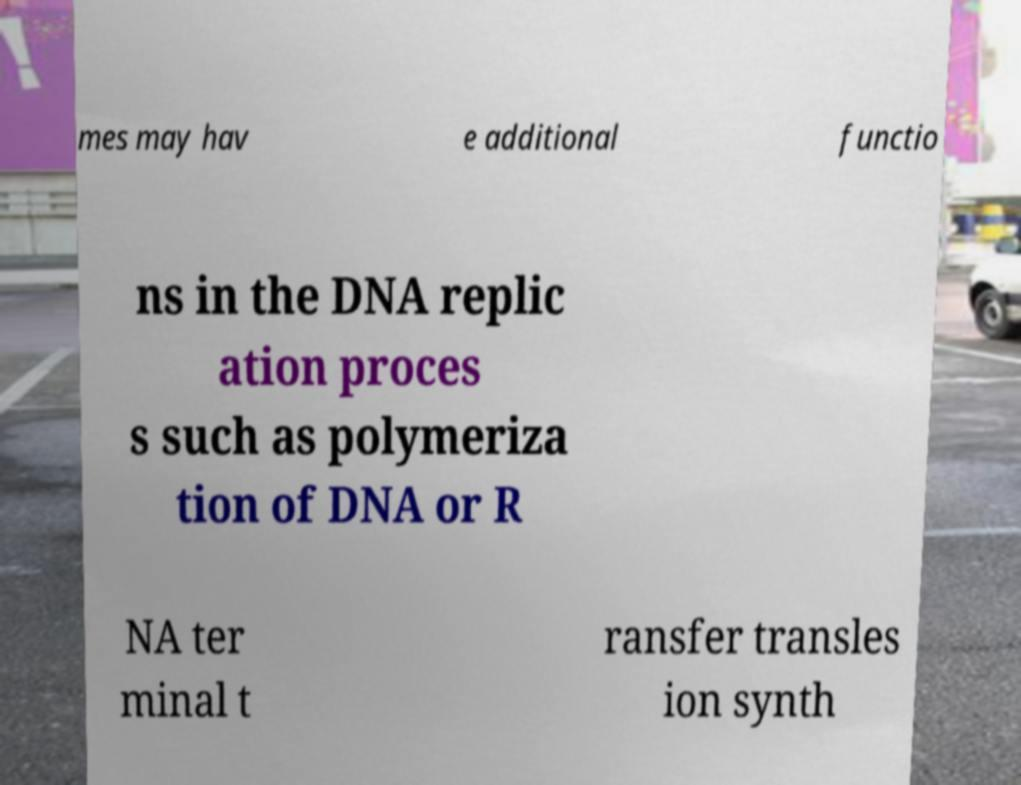I need the written content from this picture converted into text. Can you do that? mes may hav e additional functio ns in the DNA replic ation proces s such as polymeriza tion of DNA or R NA ter minal t ransfer transles ion synth 